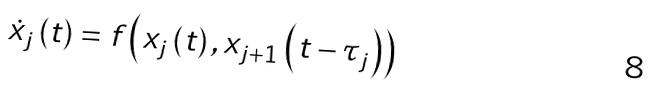Convert formula to latex. <formula><loc_0><loc_0><loc_500><loc_500>\dot { x } _ { j } \left ( t \right ) = f \left ( x _ { j } \left ( t \right ) , x _ { j + 1 } \left ( t - \tau _ { j } \right ) \right )</formula> 